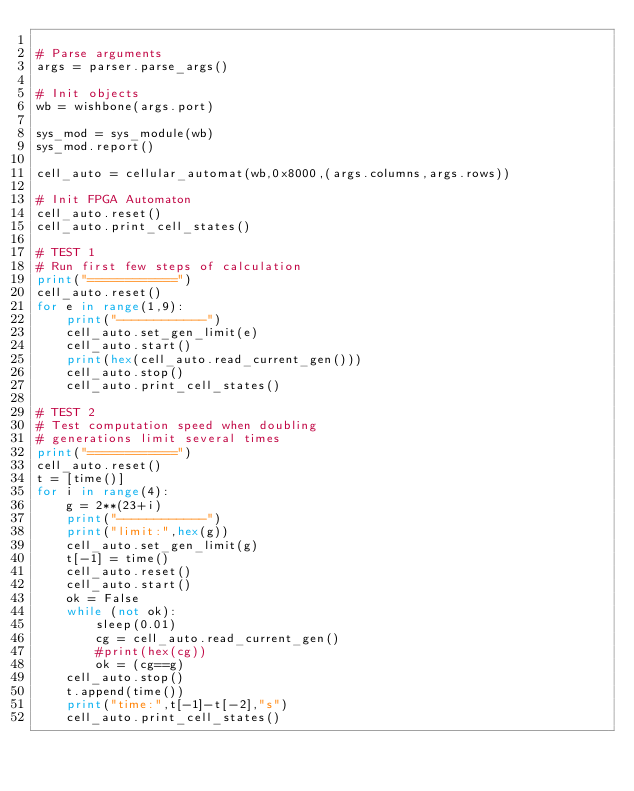Convert code to text. <code><loc_0><loc_0><loc_500><loc_500><_Python_>
# Parse arguments
args = parser.parse_args()

# Init objects
wb = wishbone(args.port)

sys_mod = sys_module(wb)
sys_mod.report()

cell_auto = cellular_automat(wb,0x8000,(args.columns,args.rows))

# Init FPGA Automaton
cell_auto.reset()
cell_auto.print_cell_states()

# TEST 1
# Run first few steps of calculation
print("============")
cell_auto.reset()
for e in range(1,9):
    print("------------")
    cell_auto.set_gen_limit(e)
    cell_auto.start()
    print(hex(cell_auto.read_current_gen()))
    cell_auto.stop()
    cell_auto.print_cell_states()

# TEST 2
# Test computation speed when doubling
# generations limit several times
print("============")
cell_auto.reset()
t = [time()]
for i in range(4):
    g = 2**(23+i)
    print("------------")
    print("limit:",hex(g))
    cell_auto.set_gen_limit(g)
    t[-1] = time()
    cell_auto.reset()
    cell_auto.start()
    ok = False
    while (not ok):
        sleep(0.01)
        cg = cell_auto.read_current_gen()
        #print(hex(cg))
        ok = (cg==g)
    cell_auto.stop()
    t.append(time())
    print("time:",t[-1]-t[-2],"s")
    cell_auto.print_cell_states()
</code> 